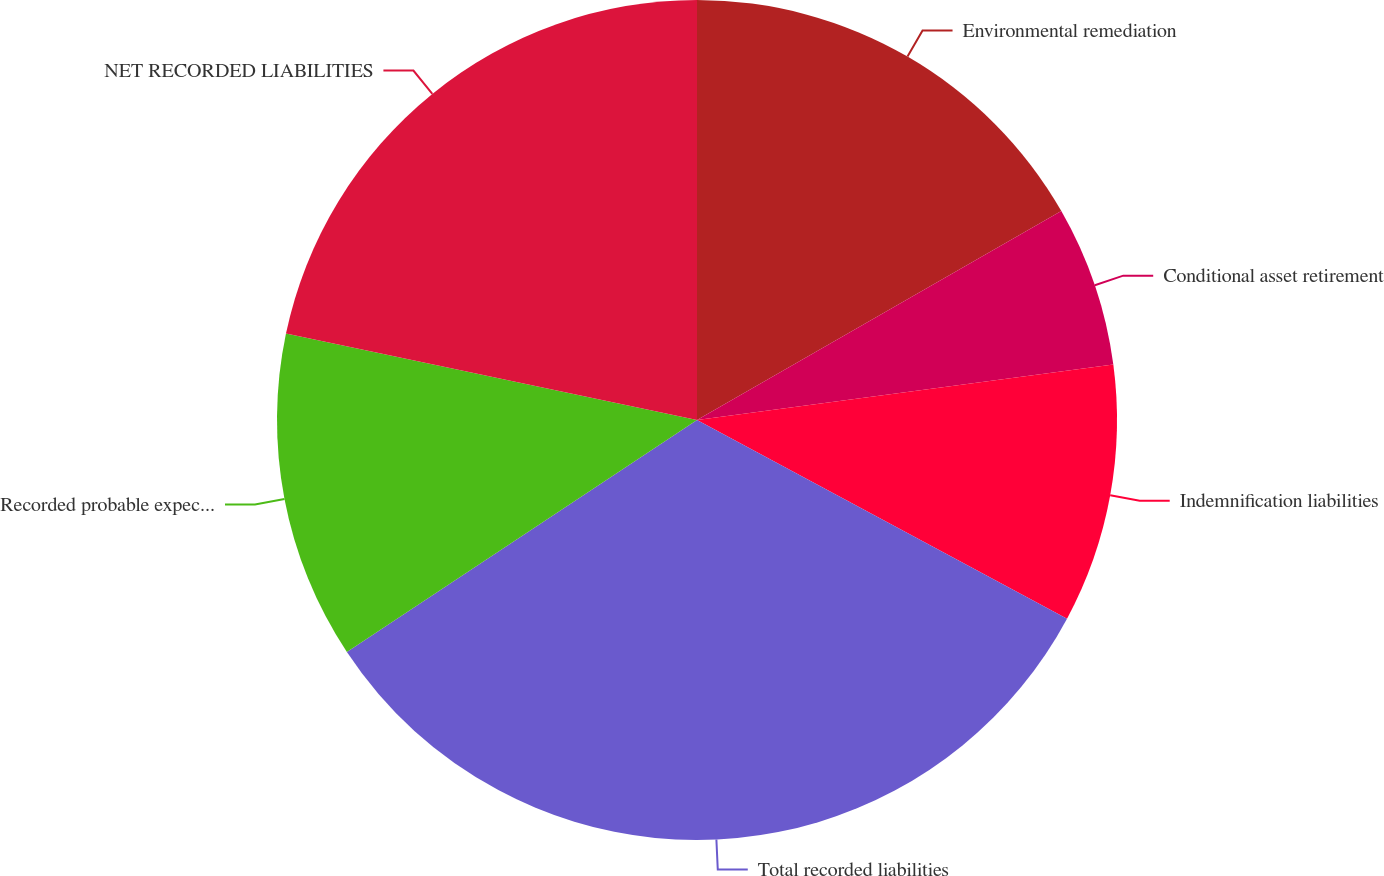Convert chart. <chart><loc_0><loc_0><loc_500><loc_500><pie_chart><fcel>Environmental remediation<fcel>Conditional asset retirement<fcel>Indemnification liabilities<fcel>Total recorded liabilities<fcel>Recorded probable expected<fcel>NET RECORDED LIABILITIES<nl><fcel>16.71%<fcel>6.18%<fcel>9.95%<fcel>32.84%<fcel>12.61%<fcel>21.7%<nl></chart> 